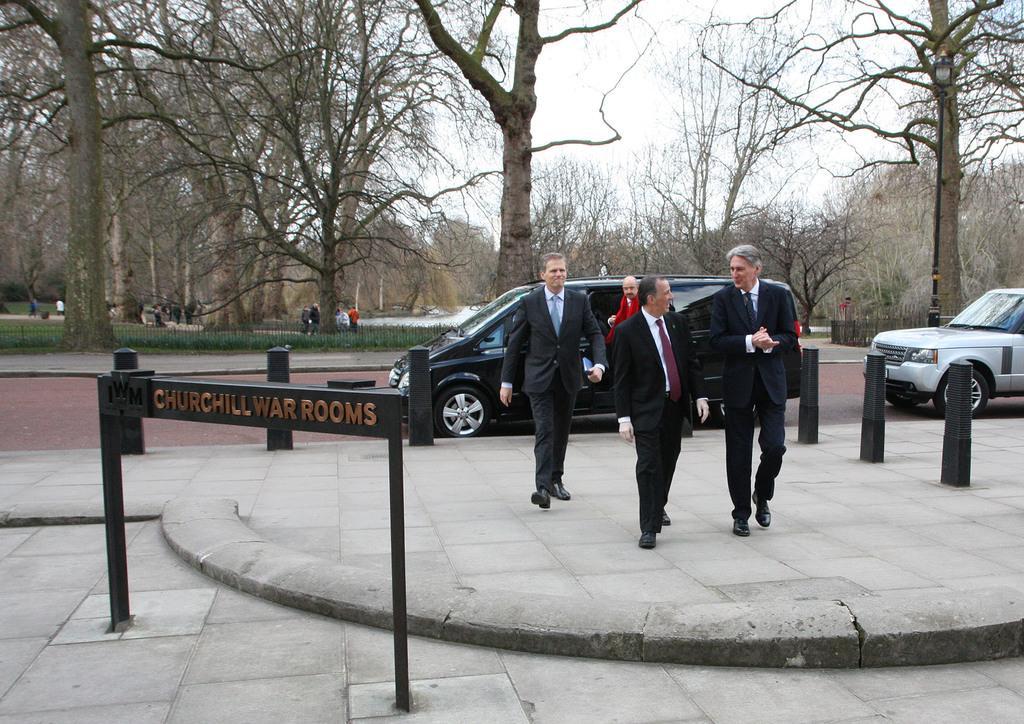Describe this image in one or two sentences. In this image we can see some group of persons wearing suits walking, in the foreground of the image there are some poles, signage boards and there are some vehicles moving on the road and in the background of the image there are some trees, persons standing and sitting here and there and top of the image there is clear sky. 